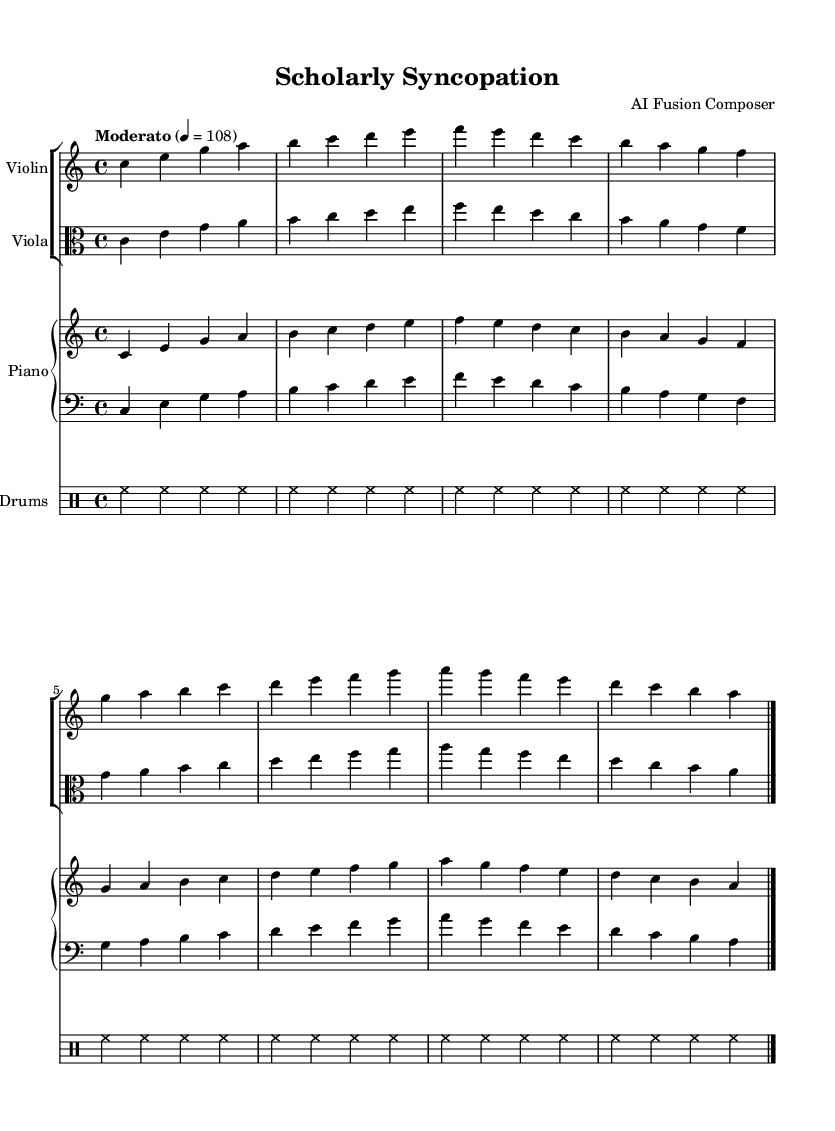What is the key signature of this music? The key signature is C major, which has no sharps or flats indicated in the music.
Answer: C major What is the time signature of this piece? The time signature is displayed at the beginning of the score and indicates how many beats are in each measure, which is 4 beats per measure.
Answer: 4/4 What is the tempo of this composition? The tempo marking "Moderato" indicates a moderate speed, and the specific metronome marking of quarter note = 108 further defines this as a tempo of 108 beats per minute.
Answer: 108 What instruments are used in this piece? The score includes a Violin, Viola, Piano, Bass, and Drums, which can be seen by identifying the labeled instrument staves.
Answer: Violin, Viola, Piano, Bass, Drums How many measures are there in the music? By counting the individual measures indicated by bar lines, we can tally a total of 8 measures within the score.
Answer: 8 Which musical styles are being fused in this piece? The piece represents a blend of Jazz and Classical music, as evident in the complex harmonies, syncopated rhythms, and orchestration typical of a fusion genre.
Answer: Jazz and Classical 